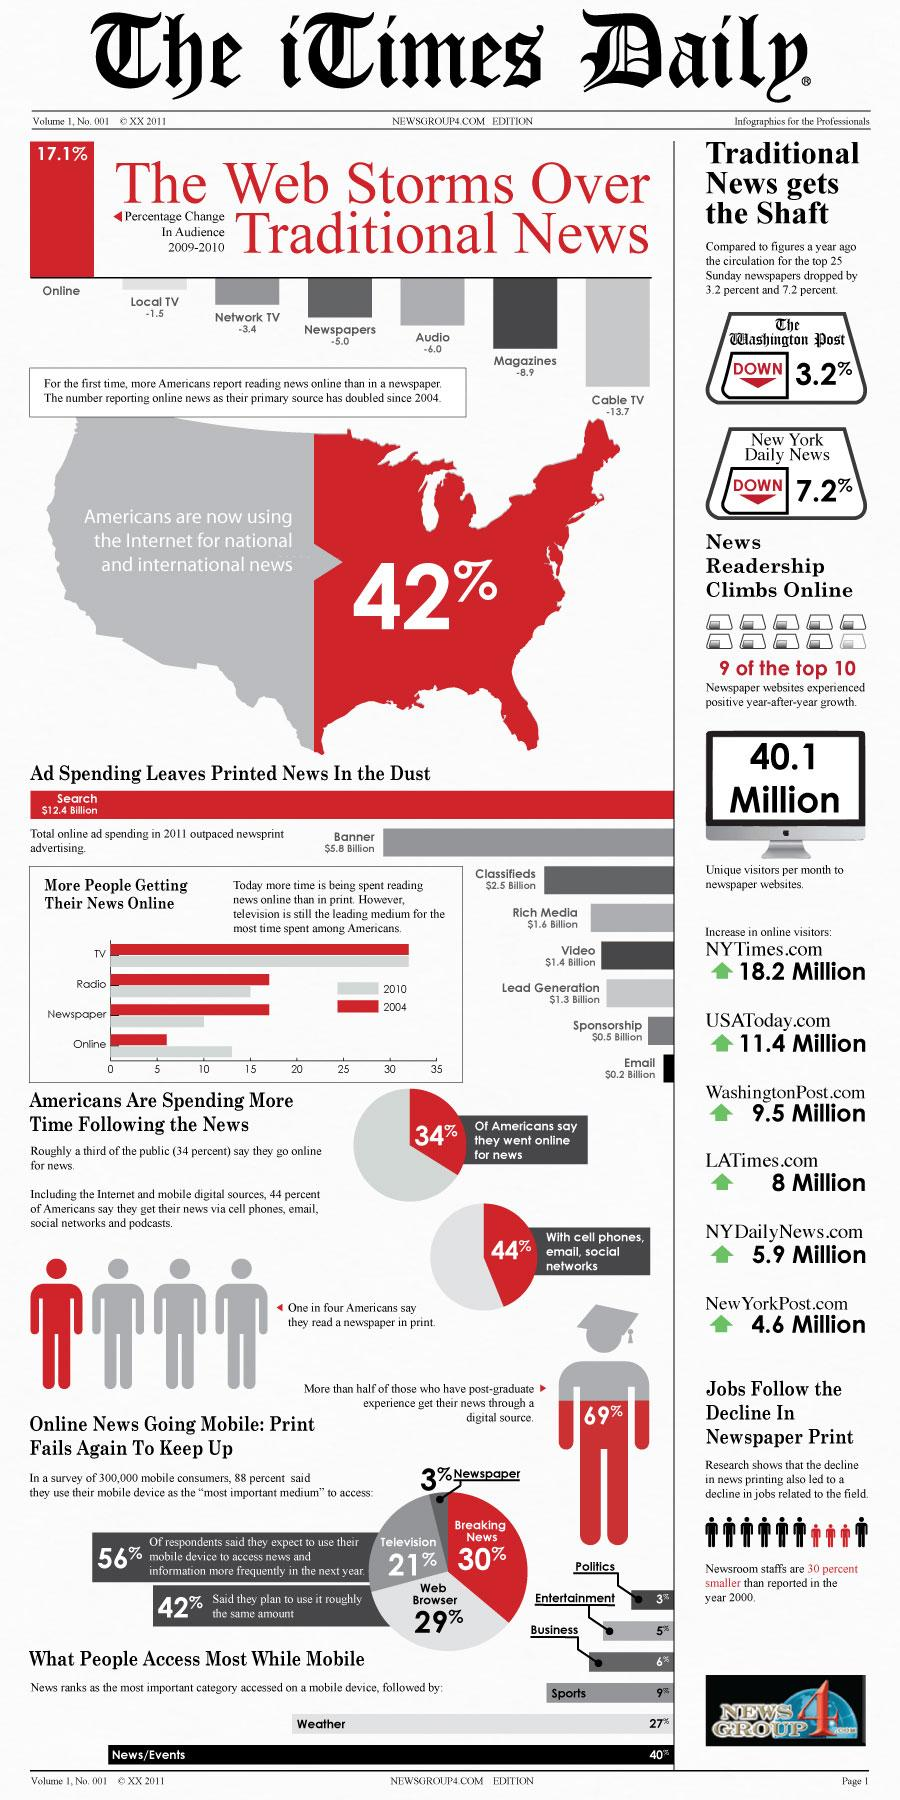Outline some significant characteristics in this image. According to data, NYTimes.com has experienced the greatest increase in the number of online visitors per month among American newspaper websites. The number of online visitors for the LATimes per month has increased by approximately 8 million. 